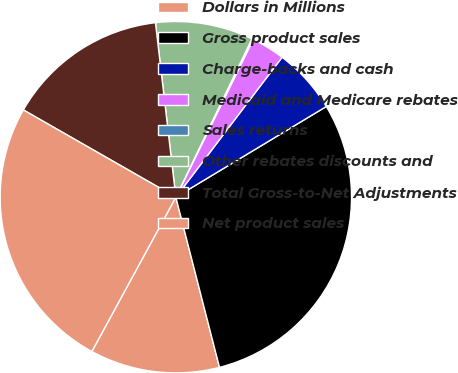<chart> <loc_0><loc_0><loc_500><loc_500><pie_chart><fcel>Dollars in Millions<fcel>Gross product sales<fcel>Charge-backs and cash<fcel>Medicaid and Medicare rebates<fcel>Sales returns<fcel>Other rebates discounts and<fcel>Total Gross-to-Net Adjustments<fcel>Net product sales<nl><fcel>11.93%<fcel>29.64%<fcel>6.03%<fcel>3.08%<fcel>0.13%<fcel>8.98%<fcel>14.88%<fcel>25.34%<nl></chart> 